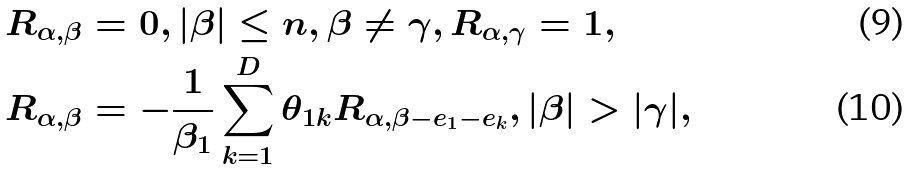<formula> <loc_0><loc_0><loc_500><loc_500>R _ { \alpha , \beta } & = 0 , | \beta | \leq n , \beta \neq \gamma , R _ { \alpha , \gamma } = 1 , \\ R _ { \alpha , \beta } & = - \frac { 1 } { \beta _ { 1 } } \sum _ { k = 1 } ^ { D } \theta _ { 1 k } R _ { \alpha , \beta - e _ { 1 } - e _ { k } } , | \beta | > | \gamma | ,</formula> 